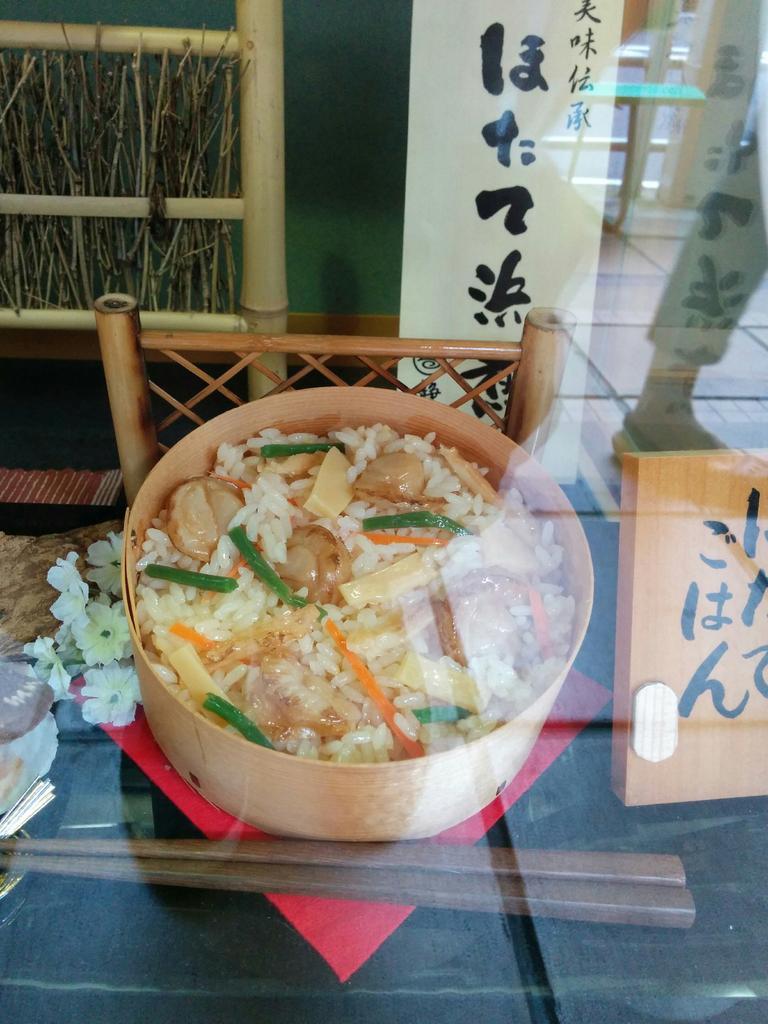Could you give a brief overview of what you see in this image? In the foreground, I can see a vessel containing food may be kept on a table. In the background, I can see a chair, a wall, board and bamboo sticks. This image taken, maybe in a hall. 